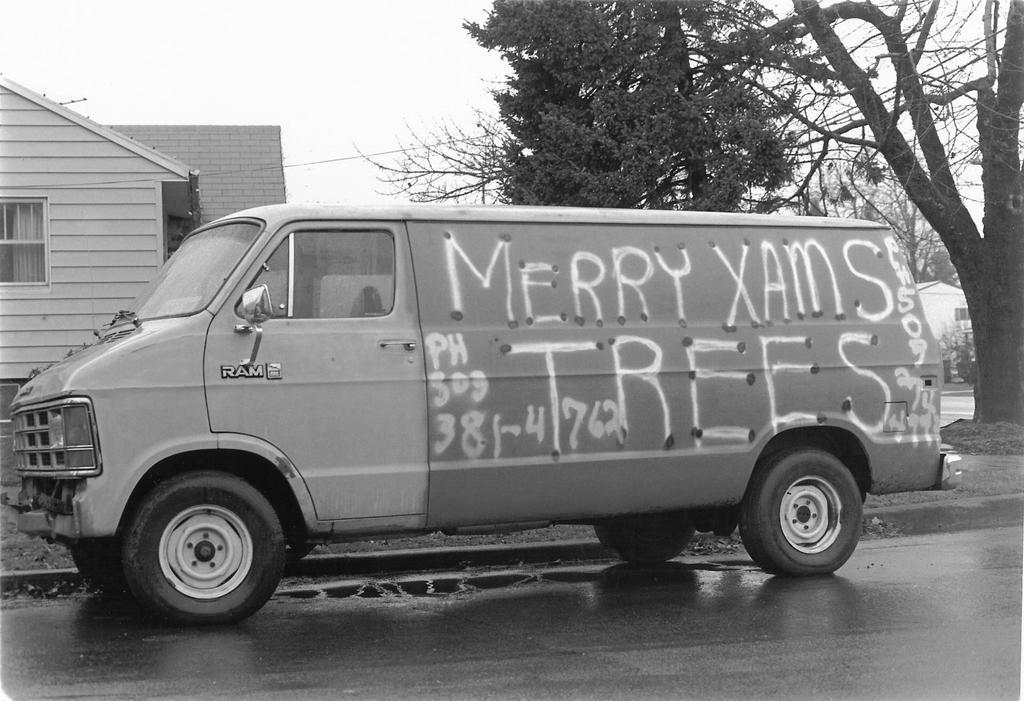Please provide a concise description of this image. It is a black and white image. In this image we can see a vehicle parked on the road. In the background we can see a building, trees and also the house. Sky is also visible. 